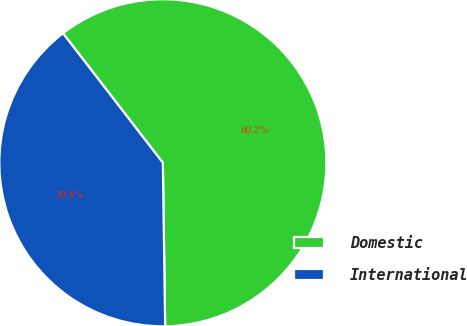Convert chart to OTSL. <chart><loc_0><loc_0><loc_500><loc_500><pie_chart><fcel>Domestic<fcel>International<nl><fcel>60.23%<fcel>39.77%<nl></chart> 